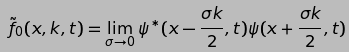Convert formula to latex. <formula><loc_0><loc_0><loc_500><loc_500>\tilde { f } _ { 0 } ( x , k , t ) = \lim _ { \sigma \rightarrow 0 } \psi ^ { * } ( x - \frac { \sigma k } { 2 } , t ) \psi ( x + \frac { \sigma k } { 2 } , t )</formula> 